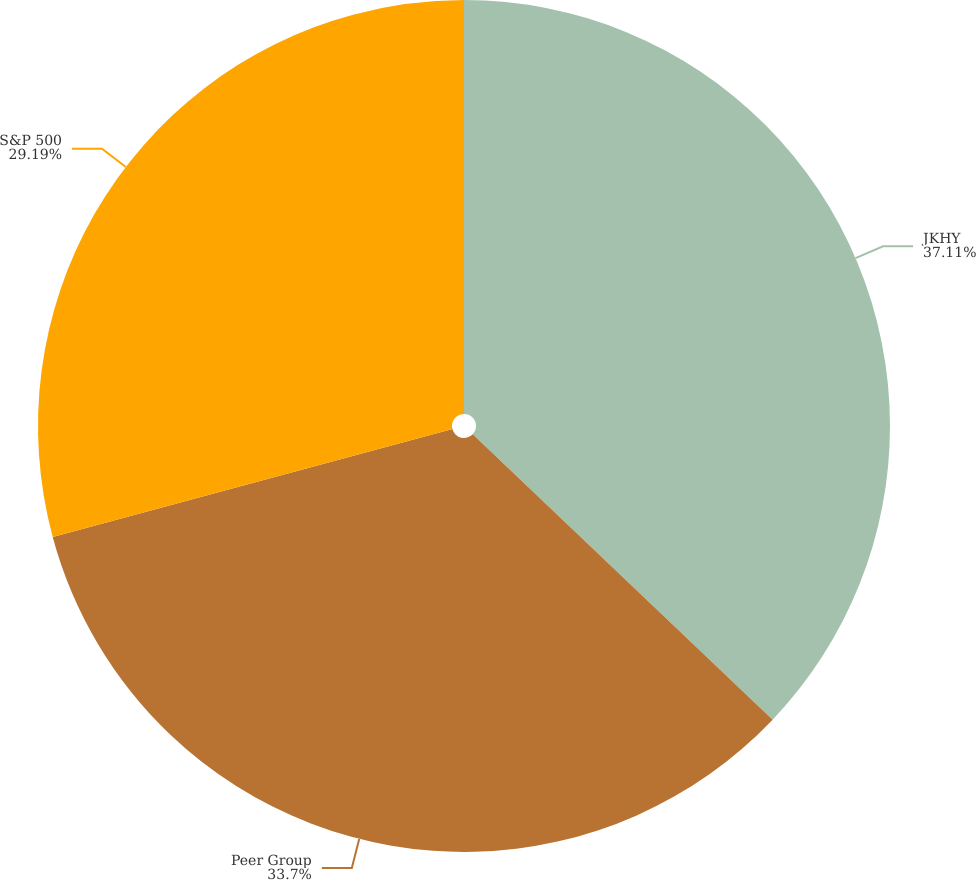Convert chart to OTSL. <chart><loc_0><loc_0><loc_500><loc_500><pie_chart><fcel>JKHY<fcel>Peer Group<fcel>S&P 500<nl><fcel>37.1%<fcel>33.7%<fcel>29.19%<nl></chart> 